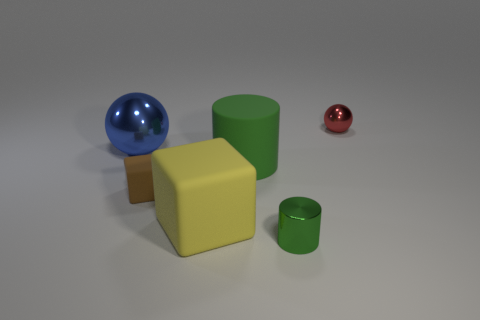Add 3 gray rubber cylinders. How many objects exist? 9 Subtract all spheres. How many objects are left? 4 Add 3 matte cylinders. How many matte cylinders are left? 4 Add 4 big green matte cylinders. How many big green matte cylinders exist? 5 Subtract 0 brown spheres. How many objects are left? 6 Subtract all green matte cylinders. Subtract all large green matte objects. How many objects are left? 4 